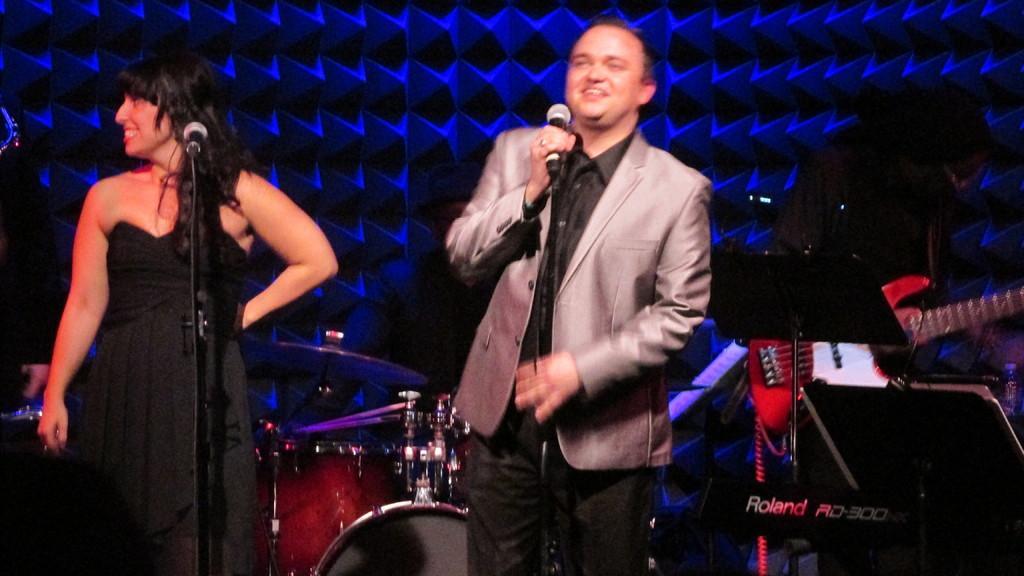Describe this image in one or two sentences. There is a person wearing suit is standing and speaking in front of a mic and there is another lady standing beside him and there is a mic in front of her and there are few musical instruments behind them and the background is blue in color. 